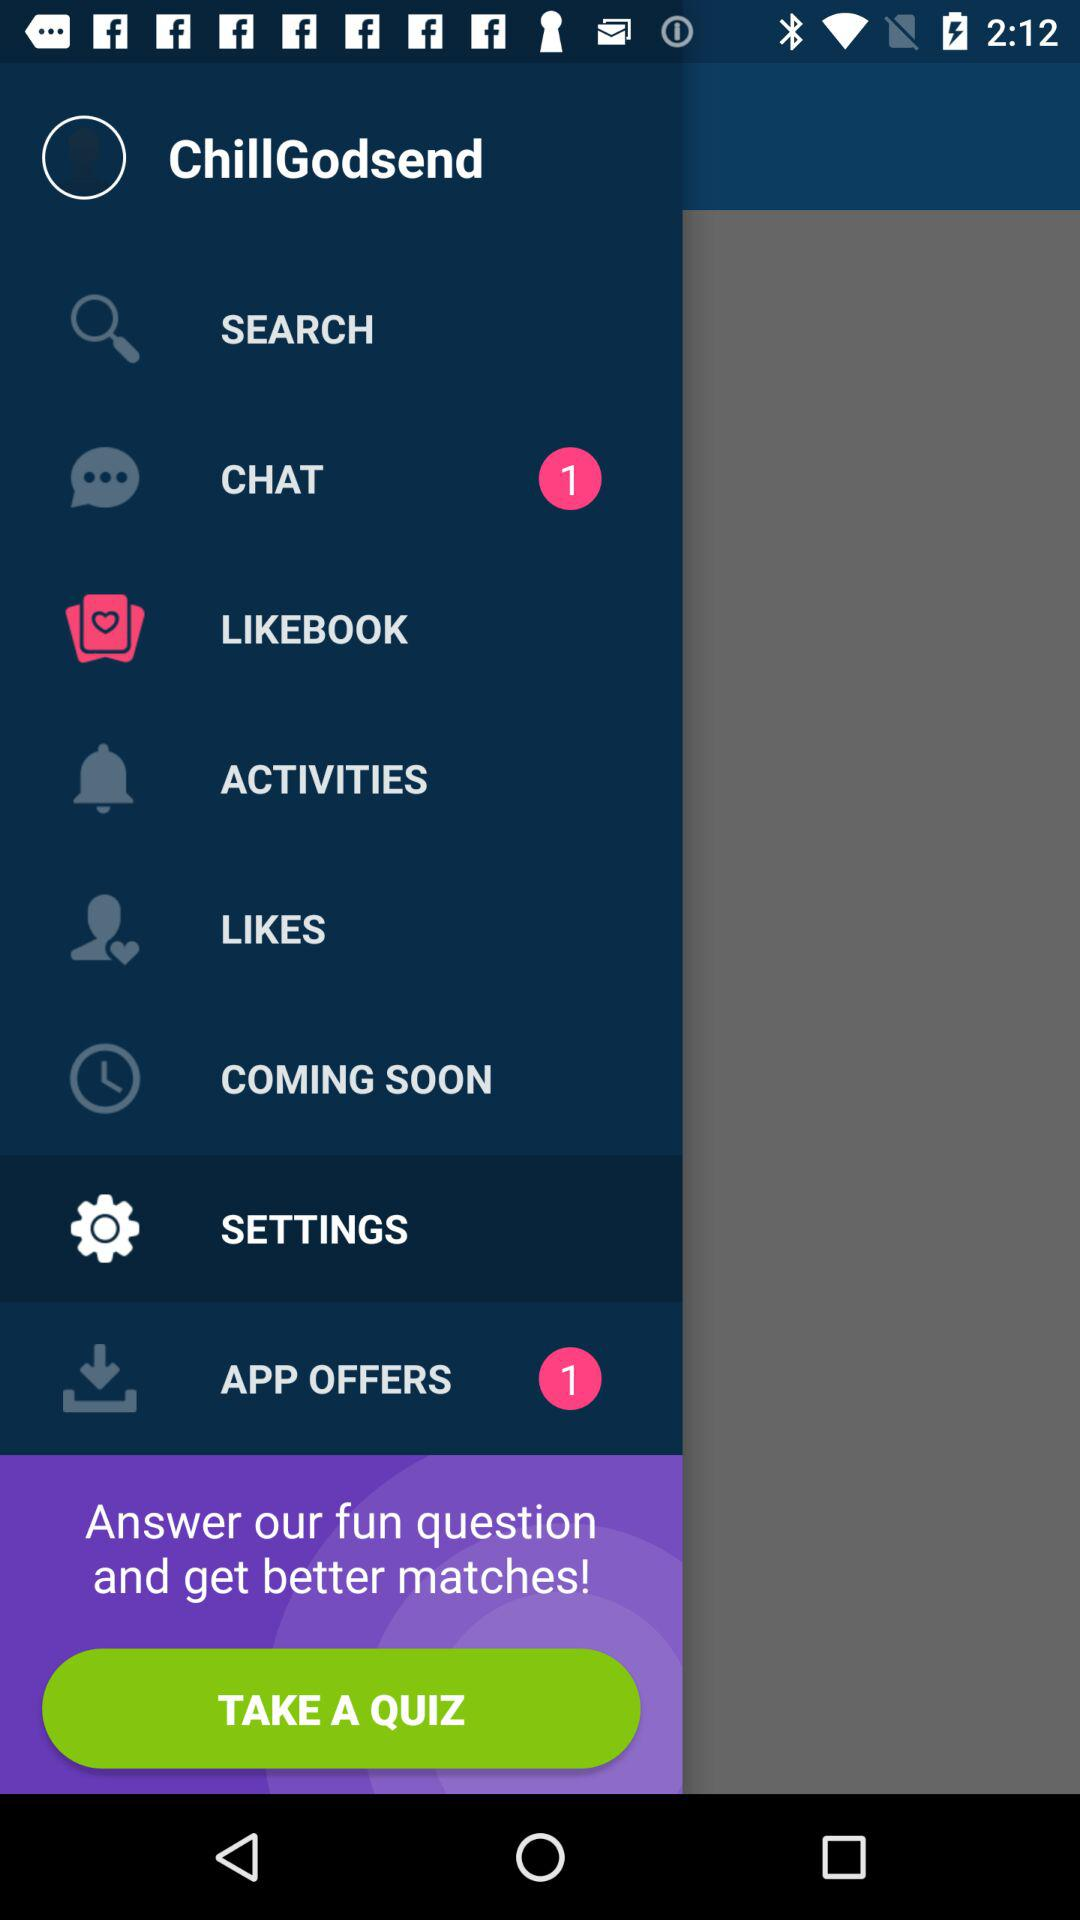Is there any unread chat? There is 1 unread chat. 